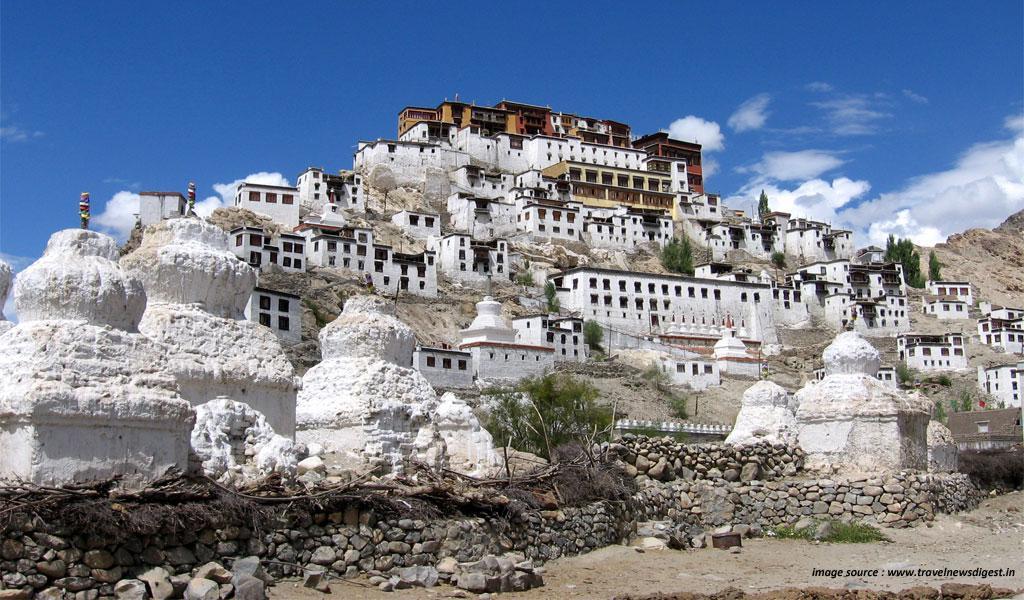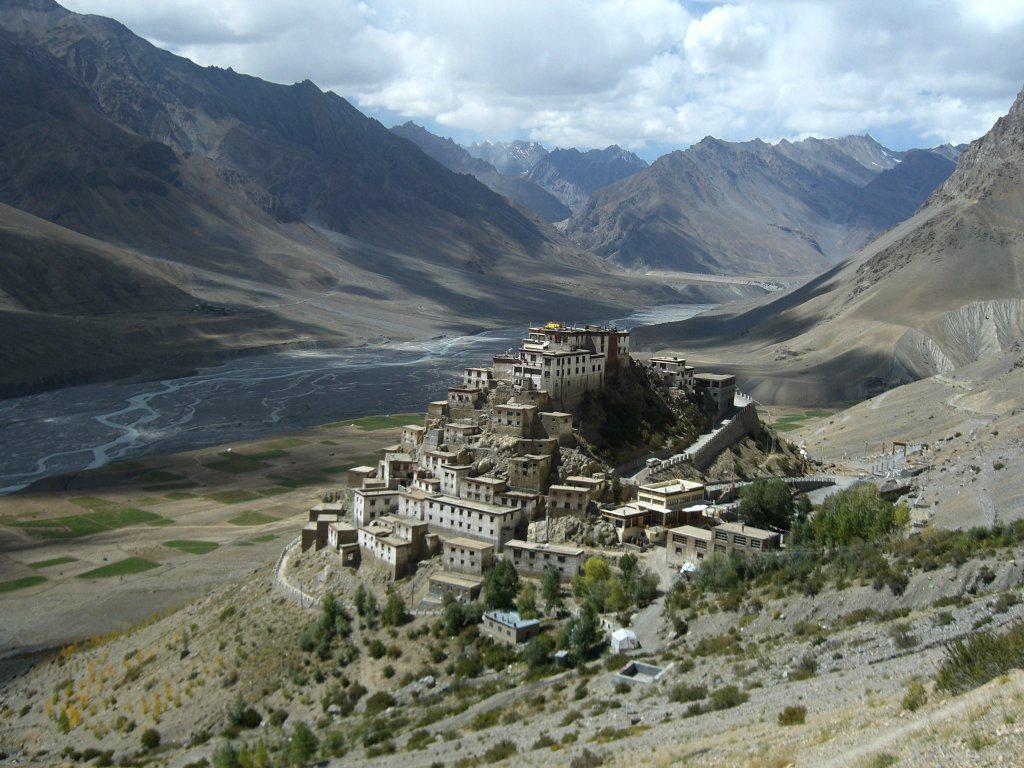The first image is the image on the left, the second image is the image on the right. Assess this claim about the two images: "In at least one image there is at least ten white house under a yellow house.". Correct or not? Answer yes or no. Yes. The first image is the image on the left, the second image is the image on the right. Given the left and right images, does the statement "Some roofs are green." hold true? Answer yes or no. No. 